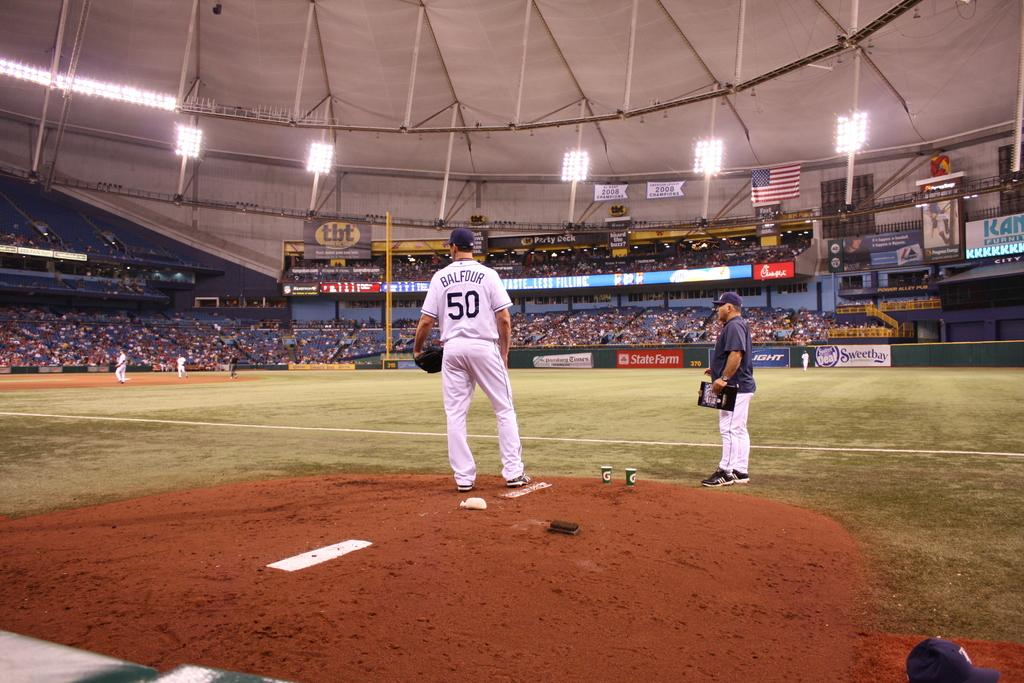<image>
Render a clear and concise summary of the photo. a person that is wearing the number 50 on their shirt 